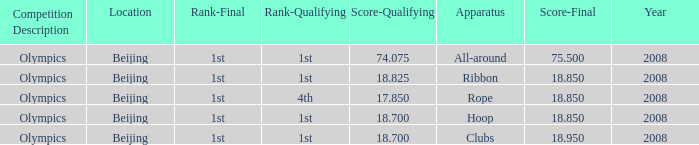On which apparatus did Kanayeva have a final score smaller than 75.5 and a qualifying score smaller than 18.7? Rope. 